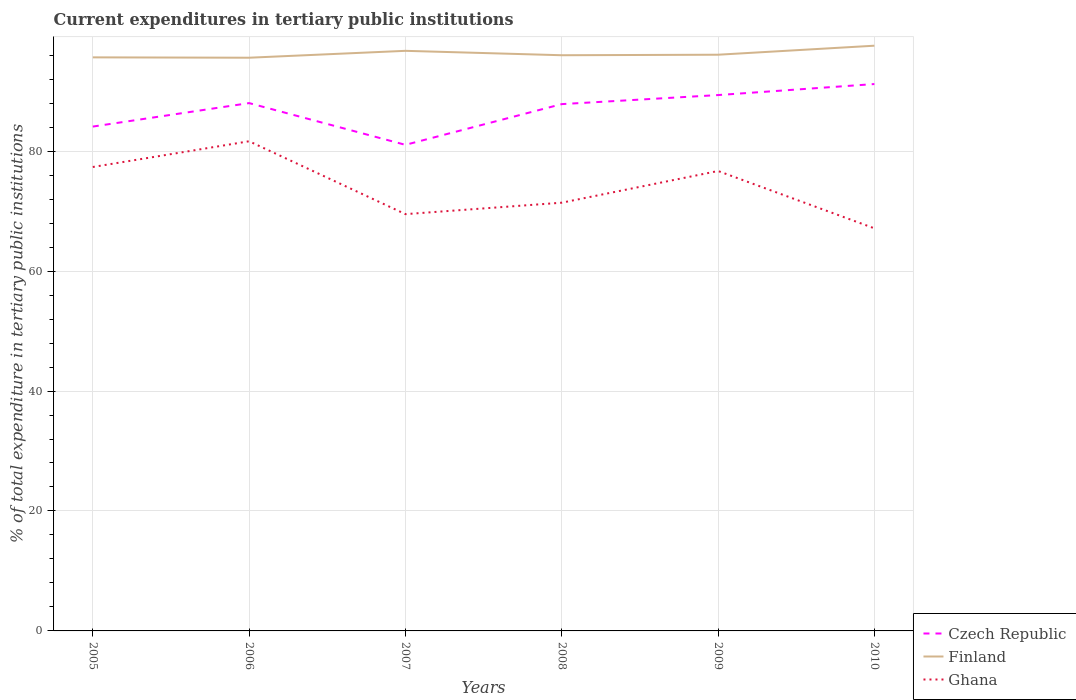How many different coloured lines are there?
Your response must be concise. 3. Is the number of lines equal to the number of legend labels?
Your answer should be very brief. Yes. Across all years, what is the maximum current expenditures in tertiary public institutions in Ghana?
Make the answer very short. 67.13. In which year was the current expenditures in tertiary public institutions in Ghana maximum?
Your answer should be compact. 2010. What is the total current expenditures in tertiary public institutions in Czech Republic in the graph?
Offer a very short reply. -3.18. What is the difference between the highest and the second highest current expenditures in tertiary public institutions in Finland?
Provide a short and direct response. 2. What is the difference between the highest and the lowest current expenditures in tertiary public institutions in Czech Republic?
Provide a succinct answer. 4. What is the difference between two consecutive major ticks on the Y-axis?
Make the answer very short. 20. Are the values on the major ticks of Y-axis written in scientific E-notation?
Ensure brevity in your answer.  No. Does the graph contain any zero values?
Offer a terse response. No. Does the graph contain grids?
Offer a very short reply. Yes. Where does the legend appear in the graph?
Your response must be concise. Bottom right. How are the legend labels stacked?
Your response must be concise. Vertical. What is the title of the graph?
Provide a succinct answer. Current expenditures in tertiary public institutions. Does "Luxembourg" appear as one of the legend labels in the graph?
Provide a succinct answer. No. What is the label or title of the X-axis?
Offer a terse response. Years. What is the label or title of the Y-axis?
Give a very brief answer. % of total expenditure in tertiary public institutions. What is the % of total expenditure in tertiary public institutions of Czech Republic in 2005?
Provide a succinct answer. 84.09. What is the % of total expenditure in tertiary public institutions of Finland in 2005?
Ensure brevity in your answer.  95.64. What is the % of total expenditure in tertiary public institutions of Ghana in 2005?
Ensure brevity in your answer.  77.35. What is the % of total expenditure in tertiary public institutions in Czech Republic in 2006?
Keep it short and to the point. 88.01. What is the % of total expenditure in tertiary public institutions in Finland in 2006?
Give a very brief answer. 95.57. What is the % of total expenditure in tertiary public institutions in Ghana in 2006?
Provide a succinct answer. 81.65. What is the % of total expenditure in tertiary public institutions of Czech Republic in 2007?
Your response must be concise. 81.05. What is the % of total expenditure in tertiary public institutions in Finland in 2007?
Keep it short and to the point. 96.72. What is the % of total expenditure in tertiary public institutions of Ghana in 2007?
Give a very brief answer. 69.49. What is the % of total expenditure in tertiary public institutions in Czech Republic in 2008?
Your response must be concise. 87.84. What is the % of total expenditure in tertiary public institutions of Finland in 2008?
Offer a very short reply. 95.99. What is the % of total expenditure in tertiary public institutions in Ghana in 2008?
Give a very brief answer. 71.4. What is the % of total expenditure in tertiary public institutions in Czech Republic in 2009?
Keep it short and to the point. 89.35. What is the % of total expenditure in tertiary public institutions of Finland in 2009?
Provide a succinct answer. 96.07. What is the % of total expenditure in tertiary public institutions of Ghana in 2009?
Keep it short and to the point. 76.69. What is the % of total expenditure in tertiary public institutions in Czech Republic in 2010?
Provide a short and direct response. 91.18. What is the % of total expenditure in tertiary public institutions in Finland in 2010?
Keep it short and to the point. 97.58. What is the % of total expenditure in tertiary public institutions of Ghana in 2010?
Offer a very short reply. 67.13. Across all years, what is the maximum % of total expenditure in tertiary public institutions in Czech Republic?
Ensure brevity in your answer.  91.18. Across all years, what is the maximum % of total expenditure in tertiary public institutions in Finland?
Provide a succinct answer. 97.58. Across all years, what is the maximum % of total expenditure in tertiary public institutions of Ghana?
Make the answer very short. 81.65. Across all years, what is the minimum % of total expenditure in tertiary public institutions of Czech Republic?
Provide a short and direct response. 81.05. Across all years, what is the minimum % of total expenditure in tertiary public institutions in Finland?
Keep it short and to the point. 95.57. Across all years, what is the minimum % of total expenditure in tertiary public institutions in Ghana?
Make the answer very short. 67.13. What is the total % of total expenditure in tertiary public institutions of Czech Republic in the graph?
Provide a short and direct response. 521.52. What is the total % of total expenditure in tertiary public institutions in Finland in the graph?
Provide a short and direct response. 577.57. What is the total % of total expenditure in tertiary public institutions in Ghana in the graph?
Your answer should be compact. 443.71. What is the difference between the % of total expenditure in tertiary public institutions in Czech Republic in 2005 and that in 2006?
Make the answer very short. -3.92. What is the difference between the % of total expenditure in tertiary public institutions in Finland in 2005 and that in 2006?
Give a very brief answer. 0.06. What is the difference between the % of total expenditure in tertiary public institutions of Ghana in 2005 and that in 2006?
Make the answer very short. -4.29. What is the difference between the % of total expenditure in tertiary public institutions of Czech Republic in 2005 and that in 2007?
Make the answer very short. 3.04. What is the difference between the % of total expenditure in tertiary public institutions of Finland in 2005 and that in 2007?
Your answer should be compact. -1.09. What is the difference between the % of total expenditure in tertiary public institutions of Ghana in 2005 and that in 2007?
Offer a very short reply. 7.86. What is the difference between the % of total expenditure in tertiary public institutions in Czech Republic in 2005 and that in 2008?
Keep it short and to the point. -3.75. What is the difference between the % of total expenditure in tertiary public institutions in Finland in 2005 and that in 2008?
Keep it short and to the point. -0.35. What is the difference between the % of total expenditure in tertiary public institutions of Ghana in 2005 and that in 2008?
Offer a very short reply. 5.95. What is the difference between the % of total expenditure in tertiary public institutions in Czech Republic in 2005 and that in 2009?
Provide a succinct answer. -5.26. What is the difference between the % of total expenditure in tertiary public institutions of Finland in 2005 and that in 2009?
Make the answer very short. -0.44. What is the difference between the % of total expenditure in tertiary public institutions in Ghana in 2005 and that in 2009?
Provide a short and direct response. 0.67. What is the difference between the % of total expenditure in tertiary public institutions of Czech Republic in 2005 and that in 2010?
Keep it short and to the point. -7.09. What is the difference between the % of total expenditure in tertiary public institutions of Finland in 2005 and that in 2010?
Provide a short and direct response. -1.94. What is the difference between the % of total expenditure in tertiary public institutions in Ghana in 2005 and that in 2010?
Provide a succinct answer. 10.22. What is the difference between the % of total expenditure in tertiary public institutions of Czech Republic in 2006 and that in 2007?
Give a very brief answer. 6.96. What is the difference between the % of total expenditure in tertiary public institutions in Finland in 2006 and that in 2007?
Offer a terse response. -1.15. What is the difference between the % of total expenditure in tertiary public institutions of Ghana in 2006 and that in 2007?
Your response must be concise. 12.15. What is the difference between the % of total expenditure in tertiary public institutions in Czech Republic in 2006 and that in 2008?
Ensure brevity in your answer.  0.17. What is the difference between the % of total expenditure in tertiary public institutions in Finland in 2006 and that in 2008?
Offer a very short reply. -0.41. What is the difference between the % of total expenditure in tertiary public institutions of Ghana in 2006 and that in 2008?
Provide a succinct answer. 10.24. What is the difference between the % of total expenditure in tertiary public institutions in Czech Republic in 2006 and that in 2009?
Provide a short and direct response. -1.34. What is the difference between the % of total expenditure in tertiary public institutions in Finland in 2006 and that in 2009?
Ensure brevity in your answer.  -0.5. What is the difference between the % of total expenditure in tertiary public institutions in Ghana in 2006 and that in 2009?
Your response must be concise. 4.96. What is the difference between the % of total expenditure in tertiary public institutions in Czech Republic in 2006 and that in 2010?
Give a very brief answer. -3.18. What is the difference between the % of total expenditure in tertiary public institutions of Finland in 2006 and that in 2010?
Your answer should be very brief. -2. What is the difference between the % of total expenditure in tertiary public institutions of Ghana in 2006 and that in 2010?
Your response must be concise. 14.52. What is the difference between the % of total expenditure in tertiary public institutions of Czech Republic in 2007 and that in 2008?
Keep it short and to the point. -6.79. What is the difference between the % of total expenditure in tertiary public institutions of Finland in 2007 and that in 2008?
Ensure brevity in your answer.  0.74. What is the difference between the % of total expenditure in tertiary public institutions in Ghana in 2007 and that in 2008?
Your answer should be very brief. -1.91. What is the difference between the % of total expenditure in tertiary public institutions of Czech Republic in 2007 and that in 2009?
Give a very brief answer. -8.3. What is the difference between the % of total expenditure in tertiary public institutions of Finland in 2007 and that in 2009?
Offer a terse response. 0.65. What is the difference between the % of total expenditure in tertiary public institutions in Ghana in 2007 and that in 2009?
Give a very brief answer. -7.19. What is the difference between the % of total expenditure in tertiary public institutions of Czech Republic in 2007 and that in 2010?
Ensure brevity in your answer.  -10.14. What is the difference between the % of total expenditure in tertiary public institutions of Finland in 2007 and that in 2010?
Offer a very short reply. -0.85. What is the difference between the % of total expenditure in tertiary public institutions in Ghana in 2007 and that in 2010?
Your response must be concise. 2.37. What is the difference between the % of total expenditure in tertiary public institutions of Czech Republic in 2008 and that in 2009?
Your response must be concise. -1.51. What is the difference between the % of total expenditure in tertiary public institutions in Finland in 2008 and that in 2009?
Give a very brief answer. -0.09. What is the difference between the % of total expenditure in tertiary public institutions in Ghana in 2008 and that in 2009?
Keep it short and to the point. -5.29. What is the difference between the % of total expenditure in tertiary public institutions in Czech Republic in 2008 and that in 2010?
Your answer should be compact. -3.35. What is the difference between the % of total expenditure in tertiary public institutions in Finland in 2008 and that in 2010?
Your answer should be compact. -1.59. What is the difference between the % of total expenditure in tertiary public institutions in Ghana in 2008 and that in 2010?
Your answer should be compact. 4.27. What is the difference between the % of total expenditure in tertiary public institutions of Czech Republic in 2009 and that in 2010?
Provide a short and direct response. -1.84. What is the difference between the % of total expenditure in tertiary public institutions of Finland in 2009 and that in 2010?
Ensure brevity in your answer.  -1.5. What is the difference between the % of total expenditure in tertiary public institutions of Ghana in 2009 and that in 2010?
Keep it short and to the point. 9.56. What is the difference between the % of total expenditure in tertiary public institutions of Czech Republic in 2005 and the % of total expenditure in tertiary public institutions of Finland in 2006?
Offer a very short reply. -11.48. What is the difference between the % of total expenditure in tertiary public institutions in Czech Republic in 2005 and the % of total expenditure in tertiary public institutions in Ghana in 2006?
Give a very brief answer. 2.45. What is the difference between the % of total expenditure in tertiary public institutions of Finland in 2005 and the % of total expenditure in tertiary public institutions of Ghana in 2006?
Give a very brief answer. 13.99. What is the difference between the % of total expenditure in tertiary public institutions of Czech Republic in 2005 and the % of total expenditure in tertiary public institutions of Finland in 2007?
Your answer should be very brief. -12.63. What is the difference between the % of total expenditure in tertiary public institutions in Czech Republic in 2005 and the % of total expenditure in tertiary public institutions in Ghana in 2007?
Give a very brief answer. 14.6. What is the difference between the % of total expenditure in tertiary public institutions of Finland in 2005 and the % of total expenditure in tertiary public institutions of Ghana in 2007?
Keep it short and to the point. 26.14. What is the difference between the % of total expenditure in tertiary public institutions in Czech Republic in 2005 and the % of total expenditure in tertiary public institutions in Finland in 2008?
Offer a very short reply. -11.9. What is the difference between the % of total expenditure in tertiary public institutions in Czech Republic in 2005 and the % of total expenditure in tertiary public institutions in Ghana in 2008?
Your answer should be very brief. 12.69. What is the difference between the % of total expenditure in tertiary public institutions in Finland in 2005 and the % of total expenditure in tertiary public institutions in Ghana in 2008?
Ensure brevity in your answer.  24.23. What is the difference between the % of total expenditure in tertiary public institutions of Czech Republic in 2005 and the % of total expenditure in tertiary public institutions of Finland in 2009?
Your response must be concise. -11.98. What is the difference between the % of total expenditure in tertiary public institutions of Czech Republic in 2005 and the % of total expenditure in tertiary public institutions of Ghana in 2009?
Your answer should be compact. 7.41. What is the difference between the % of total expenditure in tertiary public institutions of Finland in 2005 and the % of total expenditure in tertiary public institutions of Ghana in 2009?
Keep it short and to the point. 18.95. What is the difference between the % of total expenditure in tertiary public institutions of Czech Republic in 2005 and the % of total expenditure in tertiary public institutions of Finland in 2010?
Your response must be concise. -13.48. What is the difference between the % of total expenditure in tertiary public institutions of Czech Republic in 2005 and the % of total expenditure in tertiary public institutions of Ghana in 2010?
Make the answer very short. 16.96. What is the difference between the % of total expenditure in tertiary public institutions of Finland in 2005 and the % of total expenditure in tertiary public institutions of Ghana in 2010?
Keep it short and to the point. 28.51. What is the difference between the % of total expenditure in tertiary public institutions of Czech Republic in 2006 and the % of total expenditure in tertiary public institutions of Finland in 2007?
Your response must be concise. -8.72. What is the difference between the % of total expenditure in tertiary public institutions in Czech Republic in 2006 and the % of total expenditure in tertiary public institutions in Ghana in 2007?
Make the answer very short. 18.51. What is the difference between the % of total expenditure in tertiary public institutions in Finland in 2006 and the % of total expenditure in tertiary public institutions in Ghana in 2007?
Offer a terse response. 26.08. What is the difference between the % of total expenditure in tertiary public institutions in Czech Republic in 2006 and the % of total expenditure in tertiary public institutions in Finland in 2008?
Offer a very short reply. -7.98. What is the difference between the % of total expenditure in tertiary public institutions in Czech Republic in 2006 and the % of total expenditure in tertiary public institutions in Ghana in 2008?
Keep it short and to the point. 16.61. What is the difference between the % of total expenditure in tertiary public institutions of Finland in 2006 and the % of total expenditure in tertiary public institutions of Ghana in 2008?
Make the answer very short. 24.17. What is the difference between the % of total expenditure in tertiary public institutions of Czech Republic in 2006 and the % of total expenditure in tertiary public institutions of Finland in 2009?
Provide a short and direct response. -8.07. What is the difference between the % of total expenditure in tertiary public institutions in Czech Republic in 2006 and the % of total expenditure in tertiary public institutions in Ghana in 2009?
Your answer should be very brief. 11.32. What is the difference between the % of total expenditure in tertiary public institutions in Finland in 2006 and the % of total expenditure in tertiary public institutions in Ghana in 2009?
Ensure brevity in your answer.  18.89. What is the difference between the % of total expenditure in tertiary public institutions in Czech Republic in 2006 and the % of total expenditure in tertiary public institutions in Finland in 2010?
Your answer should be compact. -9.57. What is the difference between the % of total expenditure in tertiary public institutions in Czech Republic in 2006 and the % of total expenditure in tertiary public institutions in Ghana in 2010?
Offer a terse response. 20.88. What is the difference between the % of total expenditure in tertiary public institutions in Finland in 2006 and the % of total expenditure in tertiary public institutions in Ghana in 2010?
Your answer should be compact. 28.45. What is the difference between the % of total expenditure in tertiary public institutions in Czech Republic in 2007 and the % of total expenditure in tertiary public institutions in Finland in 2008?
Ensure brevity in your answer.  -14.94. What is the difference between the % of total expenditure in tertiary public institutions of Czech Republic in 2007 and the % of total expenditure in tertiary public institutions of Ghana in 2008?
Ensure brevity in your answer.  9.65. What is the difference between the % of total expenditure in tertiary public institutions in Finland in 2007 and the % of total expenditure in tertiary public institutions in Ghana in 2008?
Provide a succinct answer. 25.32. What is the difference between the % of total expenditure in tertiary public institutions in Czech Republic in 2007 and the % of total expenditure in tertiary public institutions in Finland in 2009?
Make the answer very short. -15.03. What is the difference between the % of total expenditure in tertiary public institutions of Czech Republic in 2007 and the % of total expenditure in tertiary public institutions of Ghana in 2009?
Make the answer very short. 4.36. What is the difference between the % of total expenditure in tertiary public institutions of Finland in 2007 and the % of total expenditure in tertiary public institutions of Ghana in 2009?
Offer a very short reply. 20.04. What is the difference between the % of total expenditure in tertiary public institutions in Czech Republic in 2007 and the % of total expenditure in tertiary public institutions in Finland in 2010?
Provide a short and direct response. -16.53. What is the difference between the % of total expenditure in tertiary public institutions in Czech Republic in 2007 and the % of total expenditure in tertiary public institutions in Ghana in 2010?
Give a very brief answer. 13.92. What is the difference between the % of total expenditure in tertiary public institutions in Finland in 2007 and the % of total expenditure in tertiary public institutions in Ghana in 2010?
Provide a short and direct response. 29.6. What is the difference between the % of total expenditure in tertiary public institutions of Czech Republic in 2008 and the % of total expenditure in tertiary public institutions of Finland in 2009?
Keep it short and to the point. -8.24. What is the difference between the % of total expenditure in tertiary public institutions of Czech Republic in 2008 and the % of total expenditure in tertiary public institutions of Ghana in 2009?
Offer a terse response. 11.15. What is the difference between the % of total expenditure in tertiary public institutions in Finland in 2008 and the % of total expenditure in tertiary public institutions in Ghana in 2009?
Your response must be concise. 19.3. What is the difference between the % of total expenditure in tertiary public institutions of Czech Republic in 2008 and the % of total expenditure in tertiary public institutions of Finland in 2010?
Offer a terse response. -9.74. What is the difference between the % of total expenditure in tertiary public institutions of Czech Republic in 2008 and the % of total expenditure in tertiary public institutions of Ghana in 2010?
Offer a very short reply. 20.71. What is the difference between the % of total expenditure in tertiary public institutions of Finland in 2008 and the % of total expenditure in tertiary public institutions of Ghana in 2010?
Give a very brief answer. 28.86. What is the difference between the % of total expenditure in tertiary public institutions in Czech Republic in 2009 and the % of total expenditure in tertiary public institutions in Finland in 2010?
Offer a very short reply. -8.23. What is the difference between the % of total expenditure in tertiary public institutions of Czech Republic in 2009 and the % of total expenditure in tertiary public institutions of Ghana in 2010?
Provide a succinct answer. 22.22. What is the difference between the % of total expenditure in tertiary public institutions of Finland in 2009 and the % of total expenditure in tertiary public institutions of Ghana in 2010?
Offer a terse response. 28.95. What is the average % of total expenditure in tertiary public institutions in Czech Republic per year?
Make the answer very short. 86.92. What is the average % of total expenditure in tertiary public institutions of Finland per year?
Make the answer very short. 96.26. What is the average % of total expenditure in tertiary public institutions of Ghana per year?
Offer a very short reply. 73.95. In the year 2005, what is the difference between the % of total expenditure in tertiary public institutions of Czech Republic and % of total expenditure in tertiary public institutions of Finland?
Ensure brevity in your answer.  -11.54. In the year 2005, what is the difference between the % of total expenditure in tertiary public institutions in Czech Republic and % of total expenditure in tertiary public institutions in Ghana?
Your answer should be very brief. 6.74. In the year 2005, what is the difference between the % of total expenditure in tertiary public institutions of Finland and % of total expenditure in tertiary public institutions of Ghana?
Your response must be concise. 18.28. In the year 2006, what is the difference between the % of total expenditure in tertiary public institutions in Czech Republic and % of total expenditure in tertiary public institutions in Finland?
Your answer should be compact. -7.57. In the year 2006, what is the difference between the % of total expenditure in tertiary public institutions in Czech Republic and % of total expenditure in tertiary public institutions in Ghana?
Give a very brief answer. 6.36. In the year 2006, what is the difference between the % of total expenditure in tertiary public institutions of Finland and % of total expenditure in tertiary public institutions of Ghana?
Provide a short and direct response. 13.93. In the year 2007, what is the difference between the % of total expenditure in tertiary public institutions in Czech Republic and % of total expenditure in tertiary public institutions in Finland?
Give a very brief answer. -15.68. In the year 2007, what is the difference between the % of total expenditure in tertiary public institutions of Czech Republic and % of total expenditure in tertiary public institutions of Ghana?
Provide a succinct answer. 11.55. In the year 2007, what is the difference between the % of total expenditure in tertiary public institutions in Finland and % of total expenditure in tertiary public institutions in Ghana?
Offer a very short reply. 27.23. In the year 2008, what is the difference between the % of total expenditure in tertiary public institutions of Czech Republic and % of total expenditure in tertiary public institutions of Finland?
Offer a very short reply. -8.15. In the year 2008, what is the difference between the % of total expenditure in tertiary public institutions in Czech Republic and % of total expenditure in tertiary public institutions in Ghana?
Provide a short and direct response. 16.44. In the year 2008, what is the difference between the % of total expenditure in tertiary public institutions in Finland and % of total expenditure in tertiary public institutions in Ghana?
Offer a very short reply. 24.59. In the year 2009, what is the difference between the % of total expenditure in tertiary public institutions in Czech Republic and % of total expenditure in tertiary public institutions in Finland?
Give a very brief answer. -6.73. In the year 2009, what is the difference between the % of total expenditure in tertiary public institutions in Czech Republic and % of total expenditure in tertiary public institutions in Ghana?
Keep it short and to the point. 12.66. In the year 2009, what is the difference between the % of total expenditure in tertiary public institutions in Finland and % of total expenditure in tertiary public institutions in Ghana?
Your answer should be compact. 19.39. In the year 2010, what is the difference between the % of total expenditure in tertiary public institutions of Czech Republic and % of total expenditure in tertiary public institutions of Finland?
Your answer should be compact. -6.39. In the year 2010, what is the difference between the % of total expenditure in tertiary public institutions of Czech Republic and % of total expenditure in tertiary public institutions of Ghana?
Your response must be concise. 24.06. In the year 2010, what is the difference between the % of total expenditure in tertiary public institutions of Finland and % of total expenditure in tertiary public institutions of Ghana?
Offer a terse response. 30.45. What is the ratio of the % of total expenditure in tertiary public institutions of Czech Republic in 2005 to that in 2006?
Your response must be concise. 0.96. What is the ratio of the % of total expenditure in tertiary public institutions of Finland in 2005 to that in 2006?
Offer a terse response. 1. What is the ratio of the % of total expenditure in tertiary public institutions of Ghana in 2005 to that in 2006?
Your answer should be compact. 0.95. What is the ratio of the % of total expenditure in tertiary public institutions in Czech Republic in 2005 to that in 2007?
Your response must be concise. 1.04. What is the ratio of the % of total expenditure in tertiary public institutions in Finland in 2005 to that in 2007?
Offer a terse response. 0.99. What is the ratio of the % of total expenditure in tertiary public institutions in Ghana in 2005 to that in 2007?
Your response must be concise. 1.11. What is the ratio of the % of total expenditure in tertiary public institutions of Czech Republic in 2005 to that in 2008?
Keep it short and to the point. 0.96. What is the ratio of the % of total expenditure in tertiary public institutions in Ghana in 2005 to that in 2008?
Keep it short and to the point. 1.08. What is the ratio of the % of total expenditure in tertiary public institutions of Ghana in 2005 to that in 2009?
Your answer should be very brief. 1.01. What is the ratio of the % of total expenditure in tertiary public institutions of Czech Republic in 2005 to that in 2010?
Your response must be concise. 0.92. What is the ratio of the % of total expenditure in tertiary public institutions in Finland in 2005 to that in 2010?
Your answer should be compact. 0.98. What is the ratio of the % of total expenditure in tertiary public institutions in Ghana in 2005 to that in 2010?
Give a very brief answer. 1.15. What is the ratio of the % of total expenditure in tertiary public institutions in Czech Republic in 2006 to that in 2007?
Make the answer very short. 1.09. What is the ratio of the % of total expenditure in tertiary public institutions of Ghana in 2006 to that in 2007?
Provide a short and direct response. 1.17. What is the ratio of the % of total expenditure in tertiary public institutions of Finland in 2006 to that in 2008?
Offer a very short reply. 1. What is the ratio of the % of total expenditure in tertiary public institutions in Ghana in 2006 to that in 2008?
Provide a succinct answer. 1.14. What is the ratio of the % of total expenditure in tertiary public institutions in Czech Republic in 2006 to that in 2009?
Provide a succinct answer. 0.98. What is the ratio of the % of total expenditure in tertiary public institutions in Ghana in 2006 to that in 2009?
Your answer should be very brief. 1.06. What is the ratio of the % of total expenditure in tertiary public institutions of Czech Republic in 2006 to that in 2010?
Your response must be concise. 0.97. What is the ratio of the % of total expenditure in tertiary public institutions of Finland in 2006 to that in 2010?
Offer a very short reply. 0.98. What is the ratio of the % of total expenditure in tertiary public institutions in Ghana in 2006 to that in 2010?
Give a very brief answer. 1.22. What is the ratio of the % of total expenditure in tertiary public institutions of Czech Republic in 2007 to that in 2008?
Your answer should be very brief. 0.92. What is the ratio of the % of total expenditure in tertiary public institutions in Finland in 2007 to that in 2008?
Provide a succinct answer. 1.01. What is the ratio of the % of total expenditure in tertiary public institutions in Ghana in 2007 to that in 2008?
Your answer should be compact. 0.97. What is the ratio of the % of total expenditure in tertiary public institutions in Czech Republic in 2007 to that in 2009?
Give a very brief answer. 0.91. What is the ratio of the % of total expenditure in tertiary public institutions of Finland in 2007 to that in 2009?
Your answer should be compact. 1.01. What is the ratio of the % of total expenditure in tertiary public institutions in Ghana in 2007 to that in 2009?
Offer a terse response. 0.91. What is the ratio of the % of total expenditure in tertiary public institutions of Czech Republic in 2007 to that in 2010?
Offer a terse response. 0.89. What is the ratio of the % of total expenditure in tertiary public institutions of Ghana in 2007 to that in 2010?
Provide a succinct answer. 1.04. What is the ratio of the % of total expenditure in tertiary public institutions of Czech Republic in 2008 to that in 2009?
Provide a short and direct response. 0.98. What is the ratio of the % of total expenditure in tertiary public institutions of Ghana in 2008 to that in 2009?
Your response must be concise. 0.93. What is the ratio of the % of total expenditure in tertiary public institutions of Czech Republic in 2008 to that in 2010?
Provide a succinct answer. 0.96. What is the ratio of the % of total expenditure in tertiary public institutions in Finland in 2008 to that in 2010?
Your answer should be very brief. 0.98. What is the ratio of the % of total expenditure in tertiary public institutions of Ghana in 2008 to that in 2010?
Keep it short and to the point. 1.06. What is the ratio of the % of total expenditure in tertiary public institutions of Czech Republic in 2009 to that in 2010?
Provide a succinct answer. 0.98. What is the ratio of the % of total expenditure in tertiary public institutions of Finland in 2009 to that in 2010?
Give a very brief answer. 0.98. What is the ratio of the % of total expenditure in tertiary public institutions of Ghana in 2009 to that in 2010?
Give a very brief answer. 1.14. What is the difference between the highest and the second highest % of total expenditure in tertiary public institutions of Czech Republic?
Ensure brevity in your answer.  1.84. What is the difference between the highest and the second highest % of total expenditure in tertiary public institutions in Finland?
Make the answer very short. 0.85. What is the difference between the highest and the second highest % of total expenditure in tertiary public institutions in Ghana?
Keep it short and to the point. 4.29. What is the difference between the highest and the lowest % of total expenditure in tertiary public institutions of Czech Republic?
Offer a very short reply. 10.14. What is the difference between the highest and the lowest % of total expenditure in tertiary public institutions of Finland?
Your response must be concise. 2. What is the difference between the highest and the lowest % of total expenditure in tertiary public institutions in Ghana?
Provide a short and direct response. 14.52. 